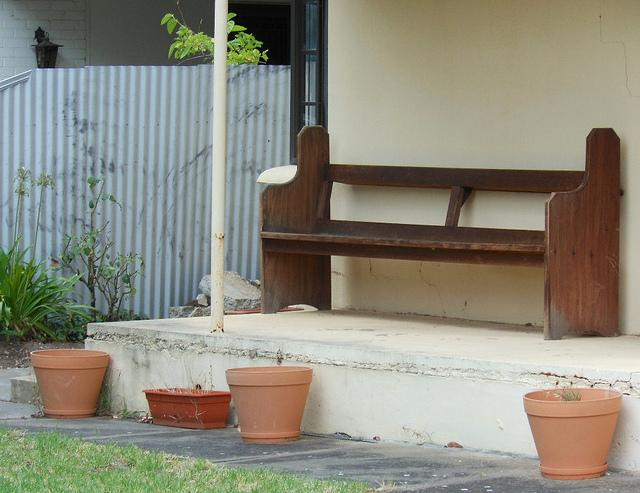What element is needed for the contents of the pots to extend their lives? Please explain your reasoning. water. Plants need water to live. 